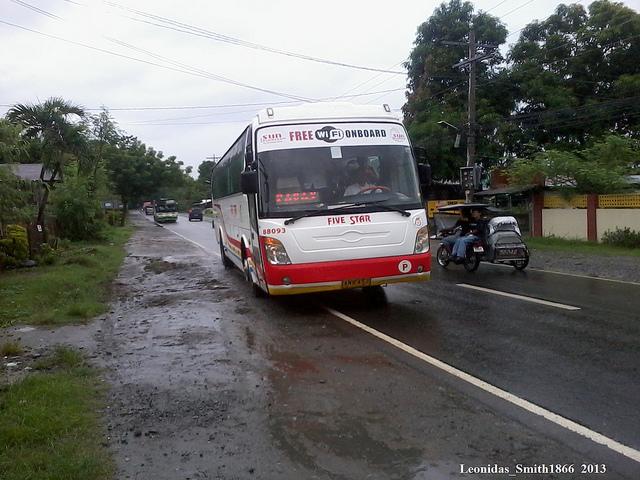Is this a Four Star bus?
Be succinct. No. Is it raining out?
Give a very brief answer. Yes. How many cars in the shot?
Write a very short answer. 2. What color is the bus?
Concise answer only. White and red. 